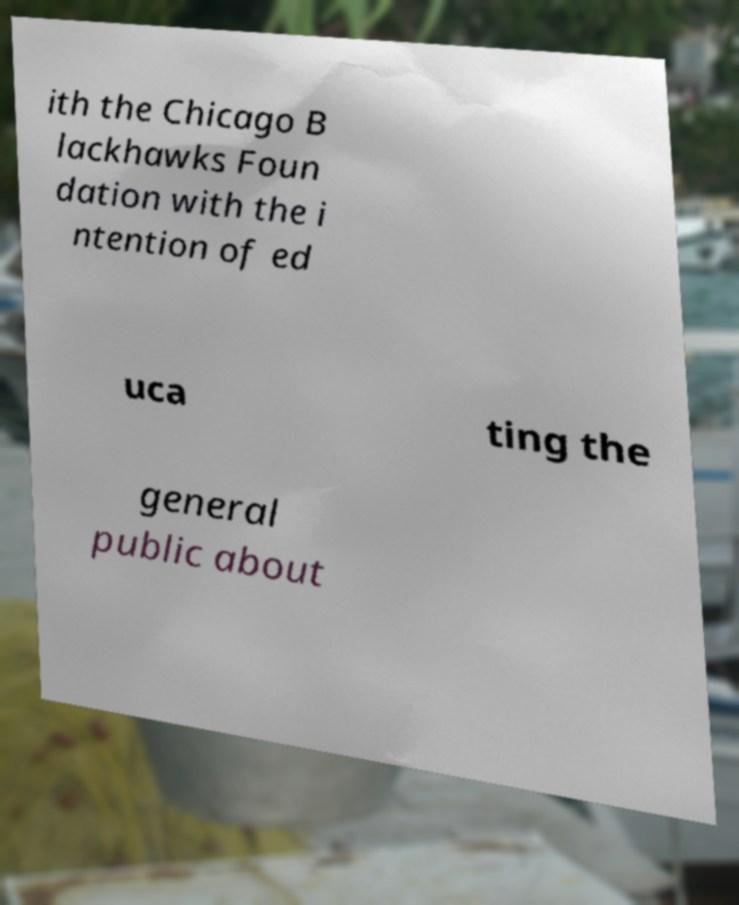Could you extract and type out the text from this image? ith the Chicago B lackhawks Foun dation with the i ntention of ed uca ting the general public about 